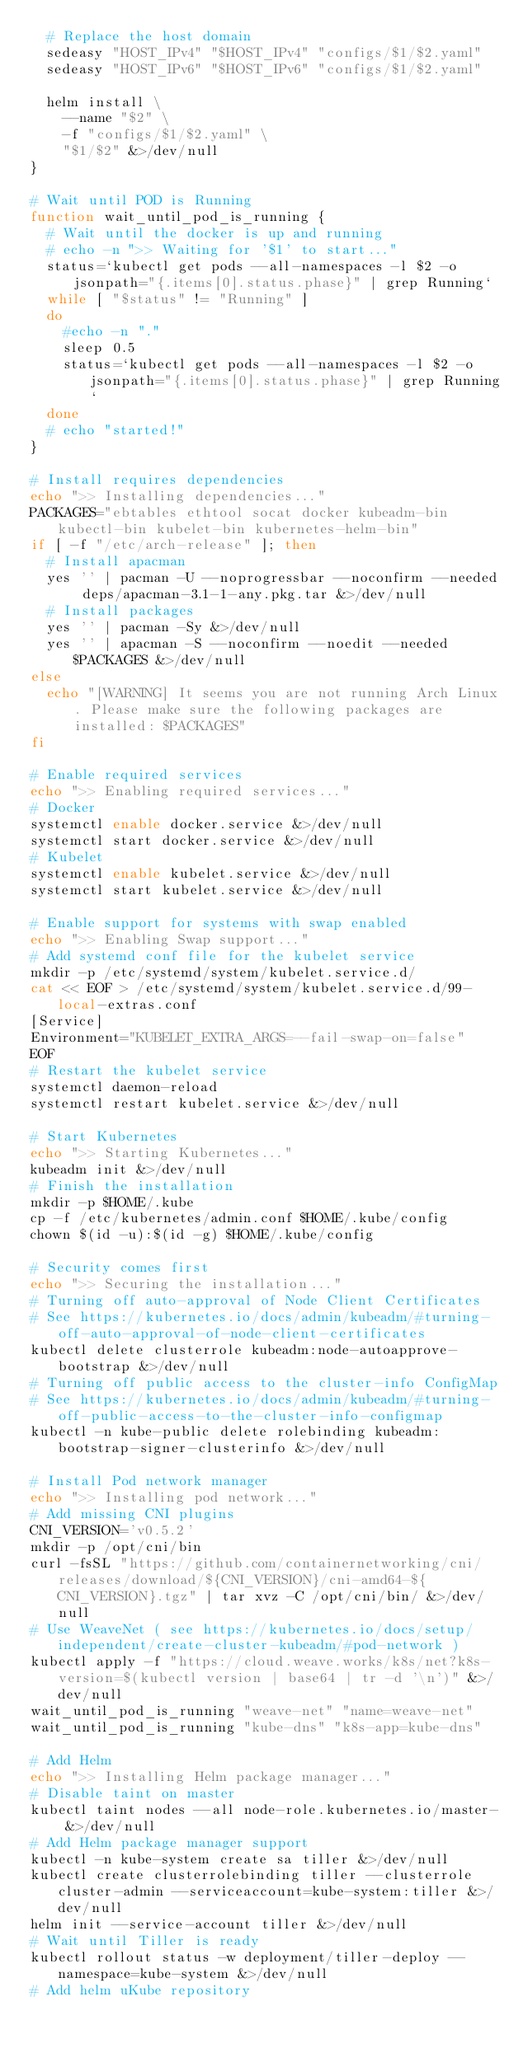Convert code to text. <code><loc_0><loc_0><loc_500><loc_500><_Bash_>  # Replace the host domain
  sedeasy "HOST_IPv4" "$HOST_IPv4" "configs/$1/$2.yaml"
  sedeasy "HOST_IPv6" "$HOST_IPv6" "configs/$1/$2.yaml"

  helm install \
    --name "$2" \
    -f "configs/$1/$2.yaml" \
    "$1/$2" &>/dev/null
}

# Wait until POD is Running
function wait_until_pod_is_running {
  # Wait until the docker is up and running
  # echo -n ">> Waiting for '$1' to start..."
  status=`kubectl get pods --all-namespaces -l $2 -o jsonpath="{.items[0].status.phase}" | grep Running`
  while [ "$status" != "Running" ]
  do
    #echo -n "."
    sleep 0.5
    status=`kubectl get pods --all-namespaces -l $2 -o jsonpath="{.items[0].status.phase}" | grep Running`
  done
  # echo "started!"
}

# Install requires dependencies
echo ">> Installing dependencies..."
PACKAGES="ebtables ethtool socat docker kubeadm-bin kubectl-bin kubelet-bin kubernetes-helm-bin"
if [ -f "/etc/arch-release" ]; then
  # Install apacman
  yes '' | pacman -U --noprogressbar --noconfirm --needed deps/apacman-3.1-1-any.pkg.tar &>/dev/null
  # Install packages
  yes '' | pacman -Sy &>/dev/null
  yes '' | apacman -S --noconfirm --noedit --needed $PACKAGES &>/dev/null
else
  echo "[WARNING] It seems you are not running Arch Linux. Please make sure the following packages are installed: $PACKAGES"
fi

# Enable required services
echo ">> Enabling required services..."
# Docker
systemctl enable docker.service &>/dev/null
systemctl start docker.service &>/dev/null
# Kubelet
systemctl enable kubelet.service &>/dev/null
systemctl start kubelet.service &>/dev/null

# Enable support for systems with swap enabled
echo ">> Enabling Swap support..."
# Add systemd conf file for the kubelet service
mkdir -p /etc/systemd/system/kubelet.service.d/
cat << EOF > /etc/systemd/system/kubelet.service.d/99-local-extras.conf
[Service]
Environment="KUBELET_EXTRA_ARGS=--fail-swap-on=false"
EOF
# Restart the kubelet service
systemctl daemon-reload
systemctl restart kubelet.service &>/dev/null

# Start Kubernetes
echo ">> Starting Kubernetes..."
kubeadm init &>/dev/null
# Finish the installation
mkdir -p $HOME/.kube
cp -f /etc/kubernetes/admin.conf $HOME/.kube/config
chown $(id -u):$(id -g) $HOME/.kube/config

# Security comes first
echo ">> Securing the installation..."
# Turning off auto-approval of Node Client Certificates
# See https://kubernetes.io/docs/admin/kubeadm/#turning-off-auto-approval-of-node-client-certificates
kubectl delete clusterrole kubeadm:node-autoapprove-bootstrap &>/dev/null
# Turning off public access to the cluster-info ConfigMap
# See https://kubernetes.io/docs/admin/kubeadm/#turning-off-public-access-to-the-cluster-info-configmap
kubectl -n kube-public delete rolebinding kubeadm:bootstrap-signer-clusterinfo &>/dev/null

# Install Pod network manager
echo ">> Installing pod network..."
# Add missing CNI plugins
CNI_VERSION='v0.5.2'
mkdir -p /opt/cni/bin
curl -fsSL "https://github.com/containernetworking/cni/releases/download/${CNI_VERSION}/cni-amd64-${CNI_VERSION}.tgz" | tar xvz -C /opt/cni/bin/ &>/dev/null
# Use WeaveNet ( see https://kubernetes.io/docs/setup/independent/create-cluster-kubeadm/#pod-network )
kubectl apply -f "https://cloud.weave.works/k8s/net?k8s-version=$(kubectl version | base64 | tr -d '\n')" &>/dev/null
wait_until_pod_is_running "weave-net" "name=weave-net"
wait_until_pod_is_running "kube-dns" "k8s-app=kube-dns"

# Add Helm
echo ">> Installing Helm package manager..."
# Disable taint on master
kubectl taint nodes --all node-role.kubernetes.io/master- &>/dev/null
# Add Helm package manager support
kubectl -n kube-system create sa tiller &>/dev/null
kubectl create clusterrolebinding tiller --clusterrole cluster-admin --serviceaccount=kube-system:tiller &>/dev/null
helm init --service-account tiller &>/dev/null
# Wait until Tiller is ready
kubectl rollout status -w deployment/tiller-deploy --namespace=kube-system &>/dev/null
# Add helm uKube repository</code> 